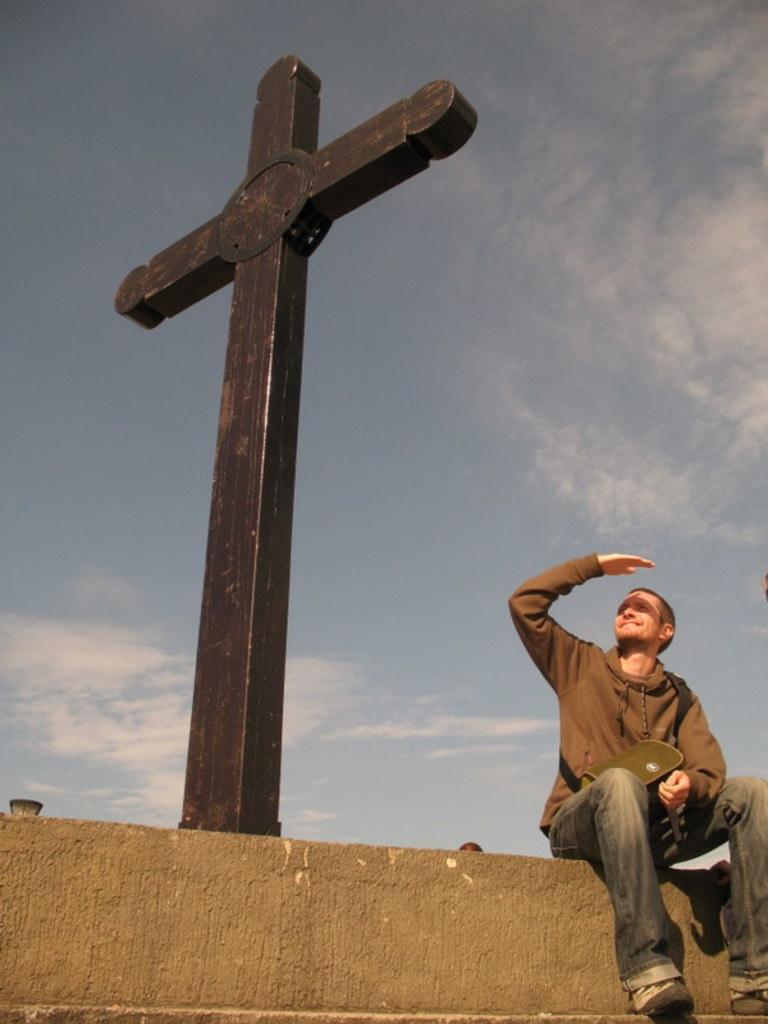How would you summarize this image in a sentence or two? In this image, on the right side, we can see a man sitting on the wall. We can see a holy cross symbol, at the top we can see the sky. 